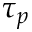<formula> <loc_0><loc_0><loc_500><loc_500>\tau _ { p }</formula> 